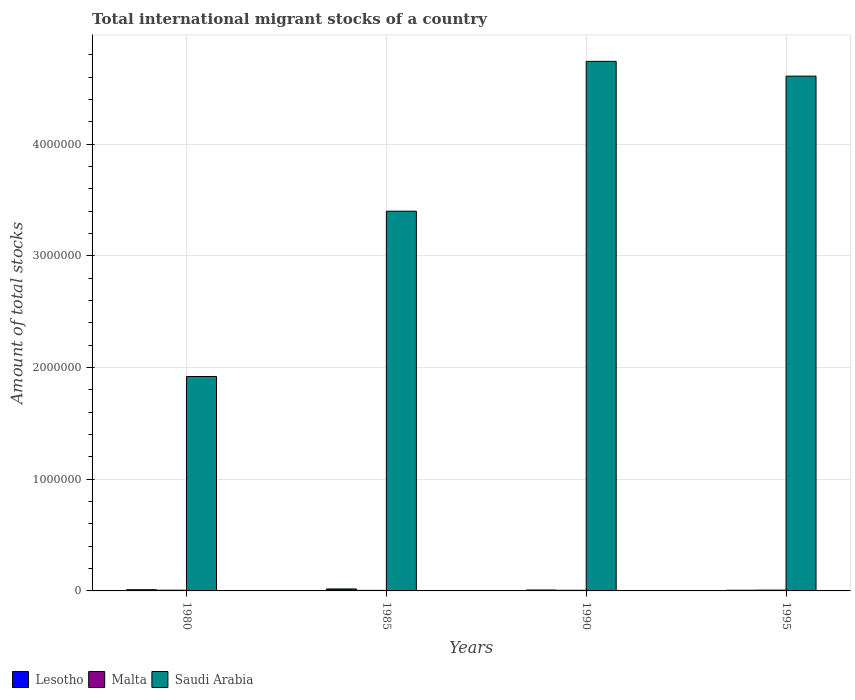How many groups of bars are there?
Offer a terse response. 4. Are the number of bars per tick equal to the number of legend labels?
Provide a short and direct response. Yes. Are the number of bars on each tick of the X-axis equal?
Make the answer very short. Yes. How many bars are there on the 4th tick from the left?
Give a very brief answer. 3. What is the label of the 3rd group of bars from the left?
Ensure brevity in your answer.  1990. What is the amount of total stocks in in Lesotho in 1985?
Provide a short and direct response. 1.75e+04. Across all years, what is the maximum amount of total stocks in in Lesotho?
Make the answer very short. 1.75e+04. Across all years, what is the minimum amount of total stocks in in Malta?
Your answer should be very brief. 4919. In which year was the amount of total stocks in in Lesotho maximum?
Your answer should be compact. 1985. What is the total amount of total stocks in in Malta in the graph?
Your answer should be compact. 2.41e+04. What is the difference between the amount of total stocks in in Saudi Arabia in 1980 and that in 1985?
Offer a very short reply. -1.48e+06. What is the difference between the amount of total stocks in in Lesotho in 1985 and the amount of total stocks in in Saudi Arabia in 1995?
Offer a very short reply. -4.59e+06. What is the average amount of total stocks in in Malta per year?
Give a very brief answer. 6025. In the year 1980, what is the difference between the amount of total stocks in in Saudi Arabia and amount of total stocks in in Malta?
Offer a terse response. 1.91e+06. In how many years, is the amount of total stocks in in Saudi Arabia greater than 2400000?
Provide a short and direct response. 3. What is the ratio of the amount of total stocks in in Lesotho in 1980 to that in 1985?
Keep it short and to the point. 0.61. What is the difference between the highest and the second highest amount of total stocks in in Lesotho?
Make the answer very short. 6873. What is the difference between the highest and the lowest amount of total stocks in in Saudi Arabia?
Offer a terse response. 2.82e+06. In how many years, is the amount of total stocks in in Saudi Arabia greater than the average amount of total stocks in in Saudi Arabia taken over all years?
Give a very brief answer. 2. Is the sum of the amount of total stocks in in Malta in 1980 and 1995 greater than the maximum amount of total stocks in in Lesotho across all years?
Give a very brief answer. No. What does the 3rd bar from the left in 1980 represents?
Provide a short and direct response. Saudi Arabia. What does the 1st bar from the right in 1995 represents?
Keep it short and to the point. Saudi Arabia. Are all the bars in the graph horizontal?
Ensure brevity in your answer.  No. How many years are there in the graph?
Give a very brief answer. 4. How many legend labels are there?
Offer a terse response. 3. How are the legend labels stacked?
Give a very brief answer. Horizontal. What is the title of the graph?
Keep it short and to the point. Total international migrant stocks of a country. Does "West Bank and Gaza" appear as one of the legend labels in the graph?
Ensure brevity in your answer.  No. What is the label or title of the X-axis?
Keep it short and to the point. Years. What is the label or title of the Y-axis?
Your answer should be compact. Amount of total stocks. What is the Amount of total stocks of Lesotho in 1980?
Ensure brevity in your answer.  1.07e+04. What is the Amount of total stocks in Malta in 1980?
Provide a short and direct response. 6313. What is the Amount of total stocks of Saudi Arabia in 1980?
Provide a short and direct response. 1.92e+06. What is the Amount of total stocks in Lesotho in 1985?
Your answer should be very brief. 1.75e+04. What is the Amount of total stocks of Malta in 1985?
Make the answer very short. 4919. What is the Amount of total stocks of Saudi Arabia in 1985?
Your answer should be very brief. 3.40e+06. What is the Amount of total stocks in Lesotho in 1990?
Your response must be concise. 8240. What is the Amount of total stocks of Malta in 1990?
Your answer should be compact. 5774. What is the Amount of total stocks in Saudi Arabia in 1990?
Ensure brevity in your answer.  4.74e+06. What is the Amount of total stocks of Lesotho in 1995?
Offer a terse response. 6116. What is the Amount of total stocks in Malta in 1995?
Ensure brevity in your answer.  7094. What is the Amount of total stocks of Saudi Arabia in 1995?
Give a very brief answer. 4.61e+06. Across all years, what is the maximum Amount of total stocks in Lesotho?
Keep it short and to the point. 1.75e+04. Across all years, what is the maximum Amount of total stocks of Malta?
Your answer should be compact. 7094. Across all years, what is the maximum Amount of total stocks of Saudi Arabia?
Offer a terse response. 4.74e+06. Across all years, what is the minimum Amount of total stocks of Lesotho?
Ensure brevity in your answer.  6116. Across all years, what is the minimum Amount of total stocks of Malta?
Give a very brief answer. 4919. Across all years, what is the minimum Amount of total stocks of Saudi Arabia?
Provide a succinct answer. 1.92e+06. What is the total Amount of total stocks of Lesotho in the graph?
Offer a terse response. 4.25e+04. What is the total Amount of total stocks in Malta in the graph?
Make the answer very short. 2.41e+04. What is the total Amount of total stocks of Saudi Arabia in the graph?
Your answer should be very brief. 1.47e+07. What is the difference between the Amount of total stocks in Lesotho in 1980 and that in 1985?
Make the answer very short. -6873. What is the difference between the Amount of total stocks of Malta in 1980 and that in 1985?
Ensure brevity in your answer.  1394. What is the difference between the Amount of total stocks in Saudi Arabia in 1980 and that in 1985?
Give a very brief answer. -1.48e+06. What is the difference between the Amount of total stocks in Lesotho in 1980 and that in 1990?
Provide a succinct answer. 2415. What is the difference between the Amount of total stocks in Malta in 1980 and that in 1990?
Give a very brief answer. 539. What is the difference between the Amount of total stocks of Saudi Arabia in 1980 and that in 1990?
Your answer should be compact. -2.82e+06. What is the difference between the Amount of total stocks in Lesotho in 1980 and that in 1995?
Offer a terse response. 4539. What is the difference between the Amount of total stocks of Malta in 1980 and that in 1995?
Give a very brief answer. -781. What is the difference between the Amount of total stocks in Saudi Arabia in 1980 and that in 1995?
Your answer should be compact. -2.69e+06. What is the difference between the Amount of total stocks in Lesotho in 1985 and that in 1990?
Ensure brevity in your answer.  9288. What is the difference between the Amount of total stocks of Malta in 1985 and that in 1990?
Your answer should be compact. -855. What is the difference between the Amount of total stocks of Saudi Arabia in 1985 and that in 1990?
Give a very brief answer. -1.34e+06. What is the difference between the Amount of total stocks of Lesotho in 1985 and that in 1995?
Provide a short and direct response. 1.14e+04. What is the difference between the Amount of total stocks in Malta in 1985 and that in 1995?
Provide a succinct answer. -2175. What is the difference between the Amount of total stocks in Saudi Arabia in 1985 and that in 1995?
Give a very brief answer. -1.21e+06. What is the difference between the Amount of total stocks of Lesotho in 1990 and that in 1995?
Your answer should be compact. 2124. What is the difference between the Amount of total stocks of Malta in 1990 and that in 1995?
Offer a very short reply. -1320. What is the difference between the Amount of total stocks of Saudi Arabia in 1990 and that in 1995?
Your answer should be very brief. 1.32e+05. What is the difference between the Amount of total stocks of Lesotho in 1980 and the Amount of total stocks of Malta in 1985?
Make the answer very short. 5736. What is the difference between the Amount of total stocks in Lesotho in 1980 and the Amount of total stocks in Saudi Arabia in 1985?
Make the answer very short. -3.39e+06. What is the difference between the Amount of total stocks in Malta in 1980 and the Amount of total stocks in Saudi Arabia in 1985?
Give a very brief answer. -3.39e+06. What is the difference between the Amount of total stocks of Lesotho in 1980 and the Amount of total stocks of Malta in 1990?
Keep it short and to the point. 4881. What is the difference between the Amount of total stocks in Lesotho in 1980 and the Amount of total stocks in Saudi Arabia in 1990?
Your answer should be very brief. -4.73e+06. What is the difference between the Amount of total stocks in Malta in 1980 and the Amount of total stocks in Saudi Arabia in 1990?
Your answer should be compact. -4.74e+06. What is the difference between the Amount of total stocks of Lesotho in 1980 and the Amount of total stocks of Malta in 1995?
Offer a very short reply. 3561. What is the difference between the Amount of total stocks of Lesotho in 1980 and the Amount of total stocks of Saudi Arabia in 1995?
Your response must be concise. -4.60e+06. What is the difference between the Amount of total stocks of Malta in 1980 and the Amount of total stocks of Saudi Arabia in 1995?
Make the answer very short. -4.60e+06. What is the difference between the Amount of total stocks of Lesotho in 1985 and the Amount of total stocks of Malta in 1990?
Your answer should be very brief. 1.18e+04. What is the difference between the Amount of total stocks in Lesotho in 1985 and the Amount of total stocks in Saudi Arabia in 1990?
Give a very brief answer. -4.73e+06. What is the difference between the Amount of total stocks of Malta in 1985 and the Amount of total stocks of Saudi Arabia in 1990?
Ensure brevity in your answer.  -4.74e+06. What is the difference between the Amount of total stocks in Lesotho in 1985 and the Amount of total stocks in Malta in 1995?
Ensure brevity in your answer.  1.04e+04. What is the difference between the Amount of total stocks of Lesotho in 1985 and the Amount of total stocks of Saudi Arabia in 1995?
Make the answer very short. -4.59e+06. What is the difference between the Amount of total stocks in Malta in 1985 and the Amount of total stocks in Saudi Arabia in 1995?
Your response must be concise. -4.61e+06. What is the difference between the Amount of total stocks of Lesotho in 1990 and the Amount of total stocks of Malta in 1995?
Provide a succinct answer. 1146. What is the difference between the Amount of total stocks of Lesotho in 1990 and the Amount of total stocks of Saudi Arabia in 1995?
Provide a succinct answer. -4.60e+06. What is the difference between the Amount of total stocks of Malta in 1990 and the Amount of total stocks of Saudi Arabia in 1995?
Keep it short and to the point. -4.60e+06. What is the average Amount of total stocks in Lesotho per year?
Provide a succinct answer. 1.06e+04. What is the average Amount of total stocks in Malta per year?
Give a very brief answer. 6025. What is the average Amount of total stocks of Saudi Arabia per year?
Give a very brief answer. 3.67e+06. In the year 1980, what is the difference between the Amount of total stocks of Lesotho and Amount of total stocks of Malta?
Your answer should be very brief. 4342. In the year 1980, what is the difference between the Amount of total stocks in Lesotho and Amount of total stocks in Saudi Arabia?
Your response must be concise. -1.91e+06. In the year 1980, what is the difference between the Amount of total stocks in Malta and Amount of total stocks in Saudi Arabia?
Your answer should be compact. -1.91e+06. In the year 1985, what is the difference between the Amount of total stocks of Lesotho and Amount of total stocks of Malta?
Your answer should be compact. 1.26e+04. In the year 1985, what is the difference between the Amount of total stocks in Lesotho and Amount of total stocks in Saudi Arabia?
Your answer should be very brief. -3.38e+06. In the year 1985, what is the difference between the Amount of total stocks in Malta and Amount of total stocks in Saudi Arabia?
Keep it short and to the point. -3.40e+06. In the year 1990, what is the difference between the Amount of total stocks in Lesotho and Amount of total stocks in Malta?
Provide a succinct answer. 2466. In the year 1990, what is the difference between the Amount of total stocks of Lesotho and Amount of total stocks of Saudi Arabia?
Give a very brief answer. -4.73e+06. In the year 1990, what is the difference between the Amount of total stocks of Malta and Amount of total stocks of Saudi Arabia?
Make the answer very short. -4.74e+06. In the year 1995, what is the difference between the Amount of total stocks in Lesotho and Amount of total stocks in Malta?
Provide a succinct answer. -978. In the year 1995, what is the difference between the Amount of total stocks of Lesotho and Amount of total stocks of Saudi Arabia?
Make the answer very short. -4.60e+06. In the year 1995, what is the difference between the Amount of total stocks in Malta and Amount of total stocks in Saudi Arabia?
Your answer should be very brief. -4.60e+06. What is the ratio of the Amount of total stocks in Lesotho in 1980 to that in 1985?
Your answer should be very brief. 0.61. What is the ratio of the Amount of total stocks of Malta in 1980 to that in 1985?
Provide a succinct answer. 1.28. What is the ratio of the Amount of total stocks in Saudi Arabia in 1980 to that in 1985?
Offer a very short reply. 0.56. What is the ratio of the Amount of total stocks of Lesotho in 1980 to that in 1990?
Provide a succinct answer. 1.29. What is the ratio of the Amount of total stocks of Malta in 1980 to that in 1990?
Offer a very short reply. 1.09. What is the ratio of the Amount of total stocks in Saudi Arabia in 1980 to that in 1990?
Make the answer very short. 0.4. What is the ratio of the Amount of total stocks in Lesotho in 1980 to that in 1995?
Keep it short and to the point. 1.74. What is the ratio of the Amount of total stocks in Malta in 1980 to that in 1995?
Your response must be concise. 0.89. What is the ratio of the Amount of total stocks of Saudi Arabia in 1980 to that in 1995?
Offer a terse response. 0.42. What is the ratio of the Amount of total stocks of Lesotho in 1985 to that in 1990?
Your response must be concise. 2.13. What is the ratio of the Amount of total stocks in Malta in 1985 to that in 1990?
Provide a short and direct response. 0.85. What is the ratio of the Amount of total stocks in Saudi Arabia in 1985 to that in 1990?
Give a very brief answer. 0.72. What is the ratio of the Amount of total stocks in Lesotho in 1985 to that in 1995?
Make the answer very short. 2.87. What is the ratio of the Amount of total stocks in Malta in 1985 to that in 1995?
Your response must be concise. 0.69. What is the ratio of the Amount of total stocks of Saudi Arabia in 1985 to that in 1995?
Give a very brief answer. 0.74. What is the ratio of the Amount of total stocks in Lesotho in 1990 to that in 1995?
Your answer should be very brief. 1.35. What is the ratio of the Amount of total stocks of Malta in 1990 to that in 1995?
Offer a very short reply. 0.81. What is the ratio of the Amount of total stocks in Saudi Arabia in 1990 to that in 1995?
Offer a very short reply. 1.03. What is the difference between the highest and the second highest Amount of total stocks in Lesotho?
Provide a succinct answer. 6873. What is the difference between the highest and the second highest Amount of total stocks of Malta?
Make the answer very short. 781. What is the difference between the highest and the second highest Amount of total stocks in Saudi Arabia?
Keep it short and to the point. 1.32e+05. What is the difference between the highest and the lowest Amount of total stocks in Lesotho?
Provide a succinct answer. 1.14e+04. What is the difference between the highest and the lowest Amount of total stocks of Malta?
Keep it short and to the point. 2175. What is the difference between the highest and the lowest Amount of total stocks in Saudi Arabia?
Give a very brief answer. 2.82e+06. 